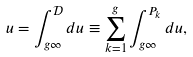Convert formula to latex. <formula><loc_0><loc_0><loc_500><loc_500>u = \int _ { g \infty } ^ { \mathcal { D } } d u \equiv \sum _ { k = 1 } ^ { g } \int _ { g \infty } ^ { P _ { k } } d u ,</formula> 